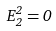Convert formula to latex. <formula><loc_0><loc_0><loc_500><loc_500>E ^ { 2 } _ { 2 } = 0</formula> 